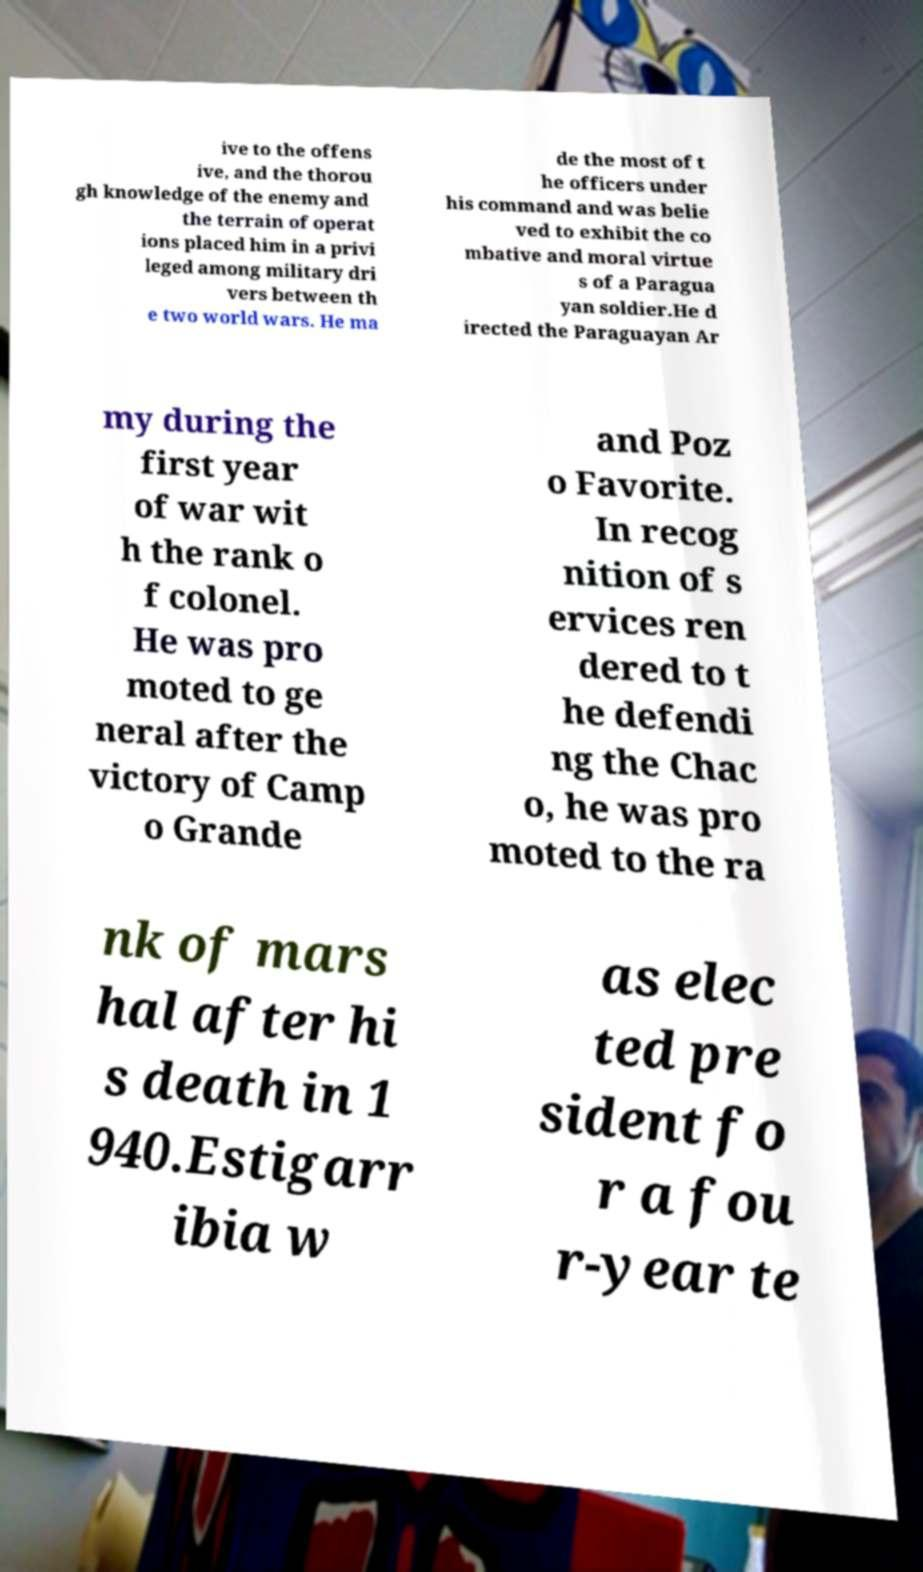Please read and relay the text visible in this image. What does it say? ive to the offens ive, and the thorou gh knowledge of the enemy and the terrain of operat ions placed him in a privi leged among military dri vers between th e two world wars. He ma de the most of t he officers under his command and was belie ved to exhibit the co mbative and moral virtue s of a Paragua yan soldier.He d irected the Paraguayan Ar my during the first year of war wit h the rank o f colonel. He was pro moted to ge neral after the victory of Camp o Grande and Poz o Favorite. In recog nition of s ervices ren dered to t he defendi ng the Chac o, he was pro moted to the ra nk of mars hal after hi s death in 1 940.Estigarr ibia w as elec ted pre sident fo r a fou r-year te 